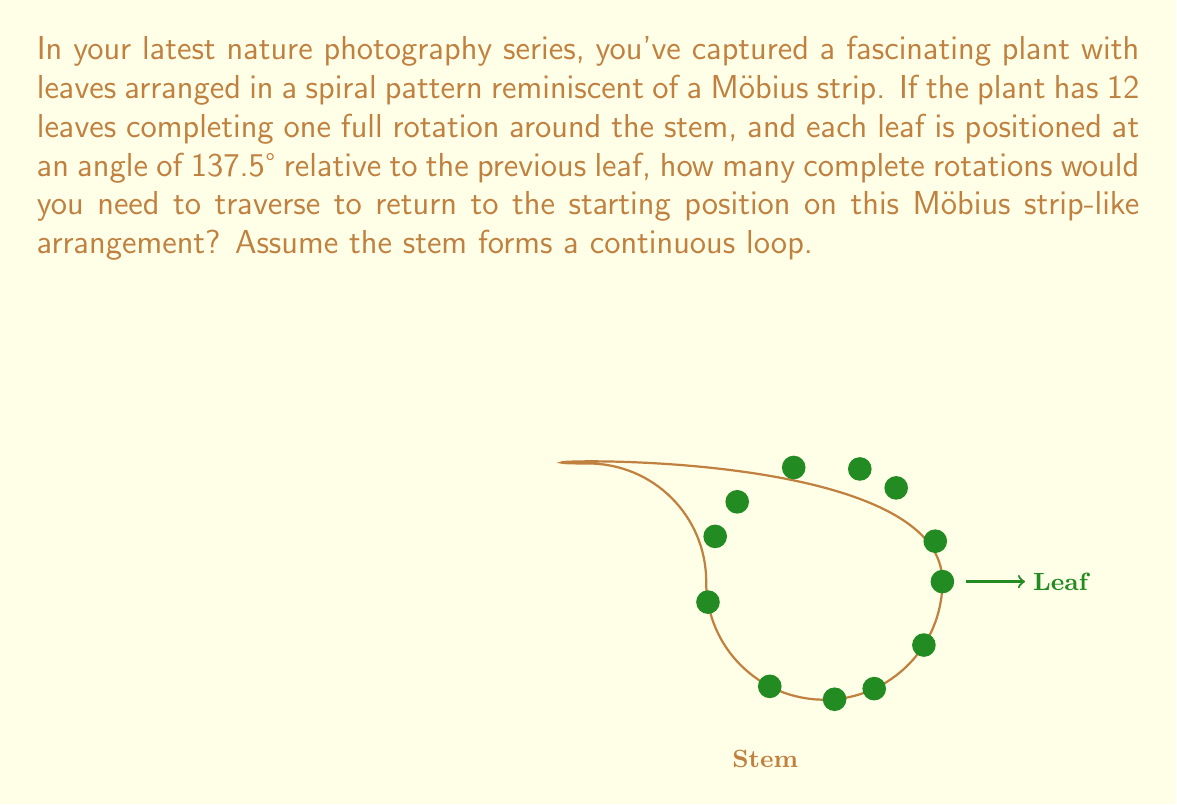Help me with this question. Let's approach this step-by-step:

1) First, we need to understand the properties of a Möbius strip. A Möbius strip has only one side and one edge. If you traverse the strip, you'll return to the starting point after two complete rotations.

2) Now, let's consider the leaf arrangement:
   - There are 12 leaves in one full rotation
   - Each leaf is positioned at an angle of 137.5° relative to the previous leaf

3) To calculate the number of rotations needed, we need to find the least common multiple (LCM) of the number of leaves and the full rotation angle (360°).

4) Let's express the leaf angle in terms of a full rotation:
   $\frac{137.5°}{360°} = \frac{11}{29}$ of a full rotation

5) Now, we need to find how many leaves it takes to complete a whole number of rotations:
   $\text{LCM}(12, 29) = 348$

6) This means after 348 leaves, we would complete a whole number of rotations in both the leaf arrangement and the full circle.

7) To find the number of rotations:
   $348 \div 12 = 29$ rotations in the leaf arrangement

8) However, remember that on a Möbius strip, we need two complete rotations to return to the starting point. So we double this:
   $29 \times 2 = 58$ rotations

Therefore, you would need to traverse 58 complete rotations on this Möbius strip-like arrangement to return to the starting position.
Answer: 58 rotations 